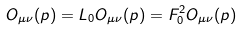Convert formula to latex. <formula><loc_0><loc_0><loc_500><loc_500>O _ { \mu \nu } ( p ) = L _ { 0 } O _ { \mu \nu } ( p ) = F _ { 0 } ^ { 2 } O _ { \mu \nu } ( p )</formula> 